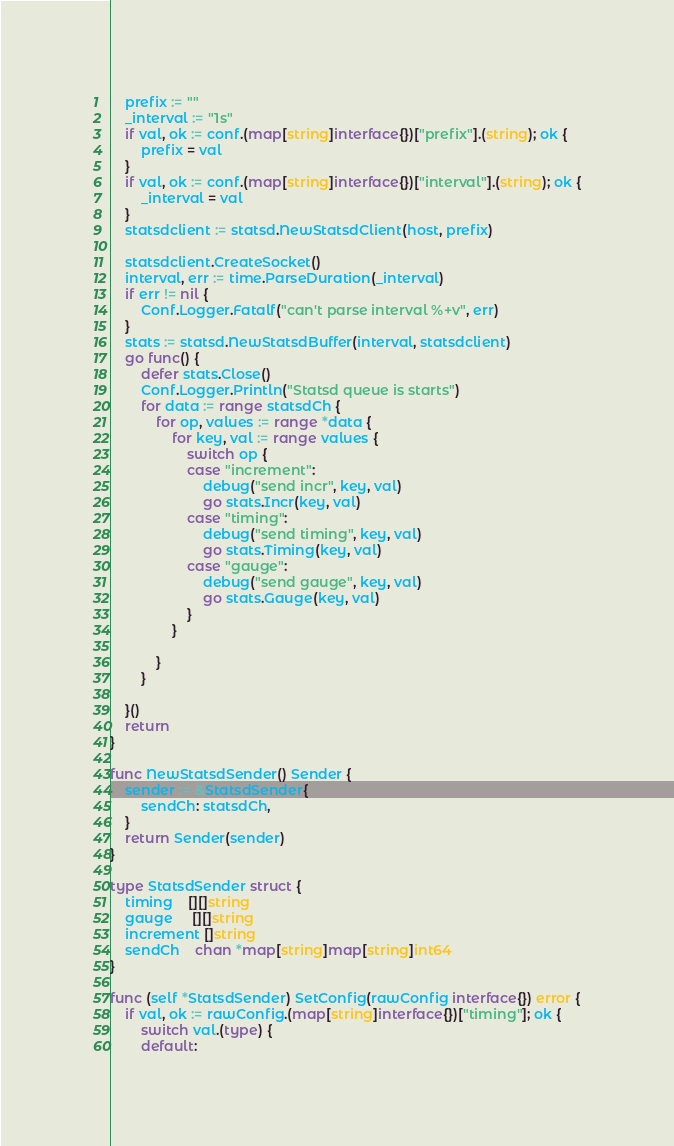Convert code to text. <code><loc_0><loc_0><loc_500><loc_500><_Go_>	prefix := ""
	_interval := "1s"
	if val, ok := conf.(map[string]interface{})["prefix"].(string); ok {
		prefix = val
	}
	if val, ok := conf.(map[string]interface{})["interval"].(string); ok {
		_interval = val
	}
	statsdclient := statsd.NewStatsdClient(host, prefix)

	statsdclient.CreateSocket()
	interval, err := time.ParseDuration(_interval)
	if err != nil {
		Conf.Logger.Fatalf("can't parse interval %+v", err)
	}
	stats := statsd.NewStatsdBuffer(interval, statsdclient)
	go func() {
		defer stats.Close()
		Conf.Logger.Println("Statsd queue is starts")
		for data := range statsdCh {
			for op, values := range *data {
				for key, val := range values {
					switch op {
					case "increment":
						debug("send incr", key, val)
						go stats.Incr(key, val)
					case "timing":
						debug("send timing", key, val)
						go stats.Timing(key, val)
					case "gauge":
						debug("send gauge", key, val)
						go stats.Gauge(key, val)
					}
				}

			}
		}

	}()
	return
}

func NewStatsdSender() Sender {
	sender := &StatsdSender{
		sendCh: statsdCh,
	}
	return Sender(sender)
}

type StatsdSender struct {
	timing    [][]string
	gauge     [][]string
	increment []string
	sendCh    chan *map[string]map[string]int64
}

func (self *StatsdSender) SetConfig(rawConfig interface{}) error {
	if val, ok := rawConfig.(map[string]interface{})["timing"]; ok {
		switch val.(type) {
		default:</code> 